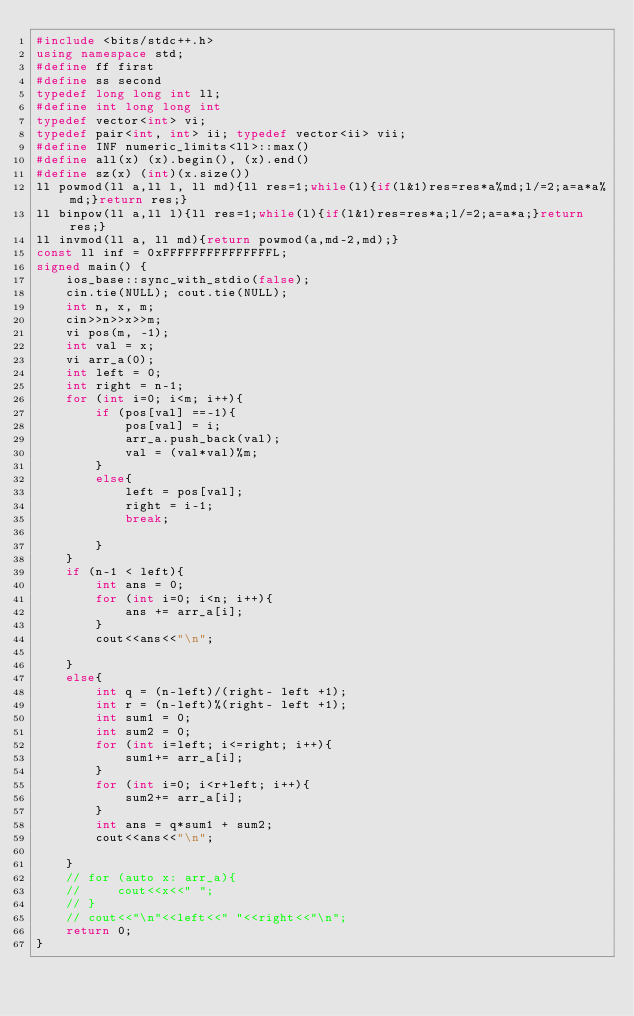<code> <loc_0><loc_0><loc_500><loc_500><_C++_>#include <bits/stdc++.h>
using namespace std;
#define ff first
#define ss second
typedef long long int ll;
#define int long long int
typedef vector<int> vi;
typedef pair<int, int> ii; typedef vector<ii> vii;
#define INF numeric_limits<ll>::max()
#define all(x) (x).begin(), (x).end()
#define sz(x) (int)(x.size())
ll powmod(ll a,ll l, ll md){ll res=1;while(l){if(l&1)res=res*a%md;l/=2;a=a*a%md;}return res;}
ll binpow(ll a,ll l){ll res=1;while(l){if(l&1)res=res*a;l/=2;a=a*a;}return res;}
ll invmod(ll a, ll md){return powmod(a,md-2,md);}
const ll inf = 0xFFFFFFFFFFFFFFFL;
signed main() {
    ios_base::sync_with_stdio(false);
    cin.tie(NULL); cout.tie(NULL);
    int n, x, m;
    cin>>n>>x>>m;
    vi pos(m, -1);
    int val = x;
    vi arr_a(0);
    int left = 0;
    int right = n-1;
    for (int i=0; i<m; i++){
        if (pos[val] ==-1){
            pos[val] = i;
            arr_a.push_back(val);
            val = (val*val)%m;
        }
        else{
            left = pos[val];
            right = i-1;
            break;

        }
    }
    if (n-1 < left){
        int ans = 0;
        for (int i=0; i<n; i++){
            ans += arr_a[i];
        }
        cout<<ans<<"\n";

    }
    else{
        int q = (n-left)/(right- left +1);
        int r = (n-left)%(right- left +1);
        int sum1 = 0;
        int sum2 = 0;
        for (int i=left; i<=right; i++){
            sum1+= arr_a[i];
        }
        for (int i=0; i<r+left; i++){
            sum2+= arr_a[i];
        }
        int ans = q*sum1 + sum2;
        cout<<ans<<"\n";

    }
    // for (auto x: arr_a){
    //     cout<<x<<" ";
    // }
    // cout<<"\n"<<left<<" "<<right<<"\n";
    return 0;
}
 </code> 